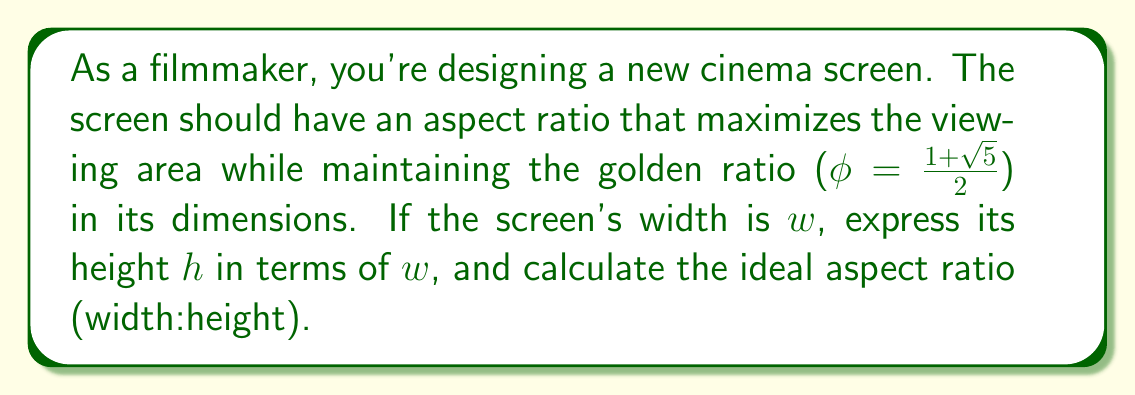What is the answer to this math problem? 1) The golden ratio is given by $\phi = \frac{1+\sqrt{5}}{2} \approx 1.618$.

2) For the screen to have the golden ratio in its dimensions, we need:
   $\frac{w}{h} = \phi$

3) Rearranging this equation:
   $h = \frac{w}{\phi}$

4) To calculate the aspect ratio, we need to express this as a ratio of whole numbers.
   Aspect ratio = $w : h = w : \frac{w}{\phi}$

5) Multiply both sides by $\phi$:
   Aspect ratio = $w\phi : w$

6) Substitute the value of $\phi$:
   Aspect ratio = $w(\frac{1+\sqrt{5}}{2}) : w$

7) Simplify:
   Aspect ratio = $\frac{w+w\sqrt{5}}{2} : w$
   Aspect ratio = $\frac{1+\sqrt{5}}{2} : 1$

8) This can be approximated as:
   Aspect ratio ≈ 1.618 : 1

9) To get whole numbers, multiply both by 1000:
   Aspect ratio ≈ 1618 : 1000

10) This can be reduced to:
    Aspect ratio = 16:10 (or 8:5)
Answer: 16:10 (or 8:5) 